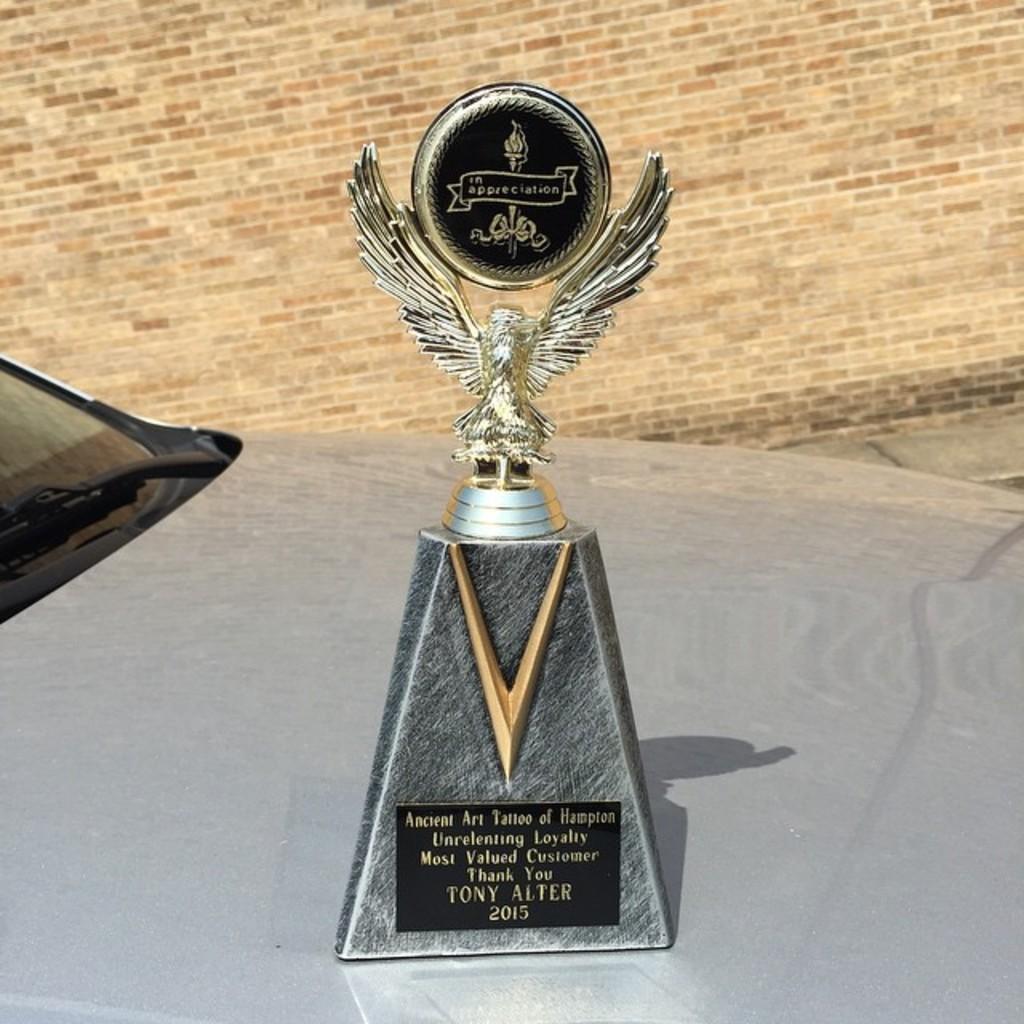What is the year listed on this trophy?
Offer a terse response. 2015. Who was this trophy awarded to?
Provide a short and direct response. Tony alter. 